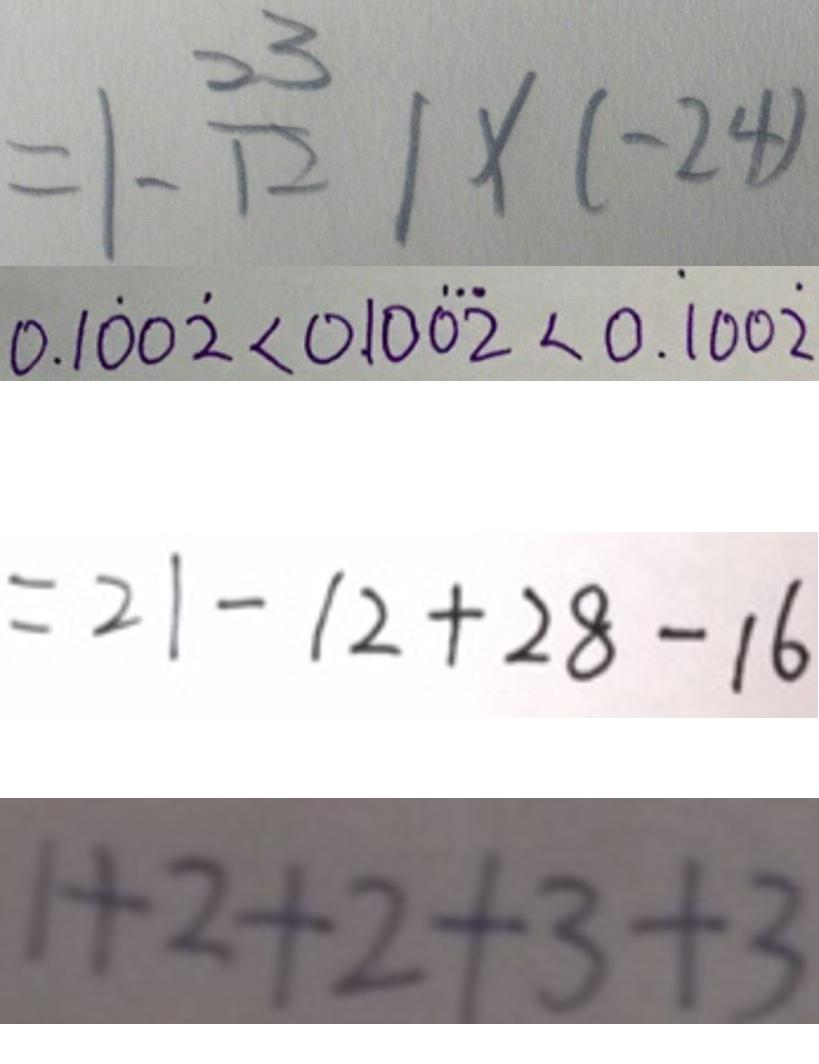<formula> <loc_0><loc_0><loc_500><loc_500>= \vert - \frac { 3 3 } { 1 2 } \vert \times ( - 2 4 ) 
 0 . 1 \dot { 0 } 0 \dot { 2 } < 0 . 1 0 \dot { 0 } \dot { 2 } < 0 . \dot { 1 } 0 0 \dot { 2 } 
 = 2 1 - 1 2 + 2 8 - 1 6 
 1 + 2 + 2 + 3 + 3</formula> 